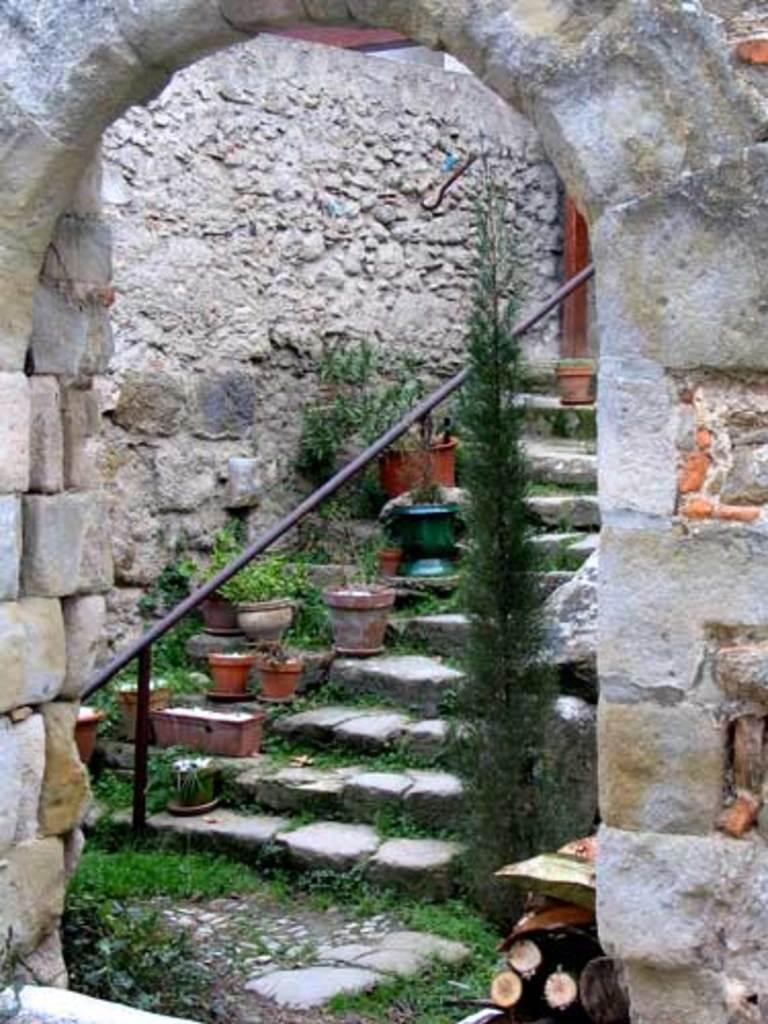In one or two sentences, can you explain what this image depicts? In this image there is an arch and behind the arch we can see plants and also stairs. 